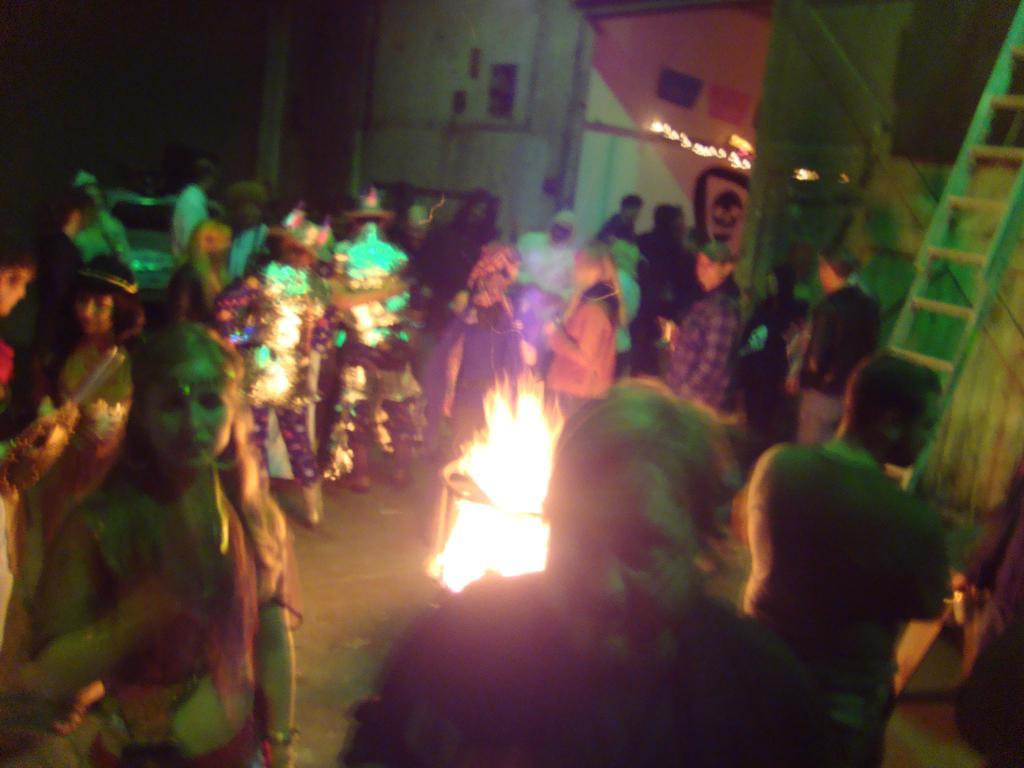Please provide a concise description of this image. In this picture I can observe some people standing around the fire. There are men and women in this picture. Some of them are wearing costumes. I can observe fire in the middle of the picture. On the right side there is a ladder. In the background I can observe a house. 